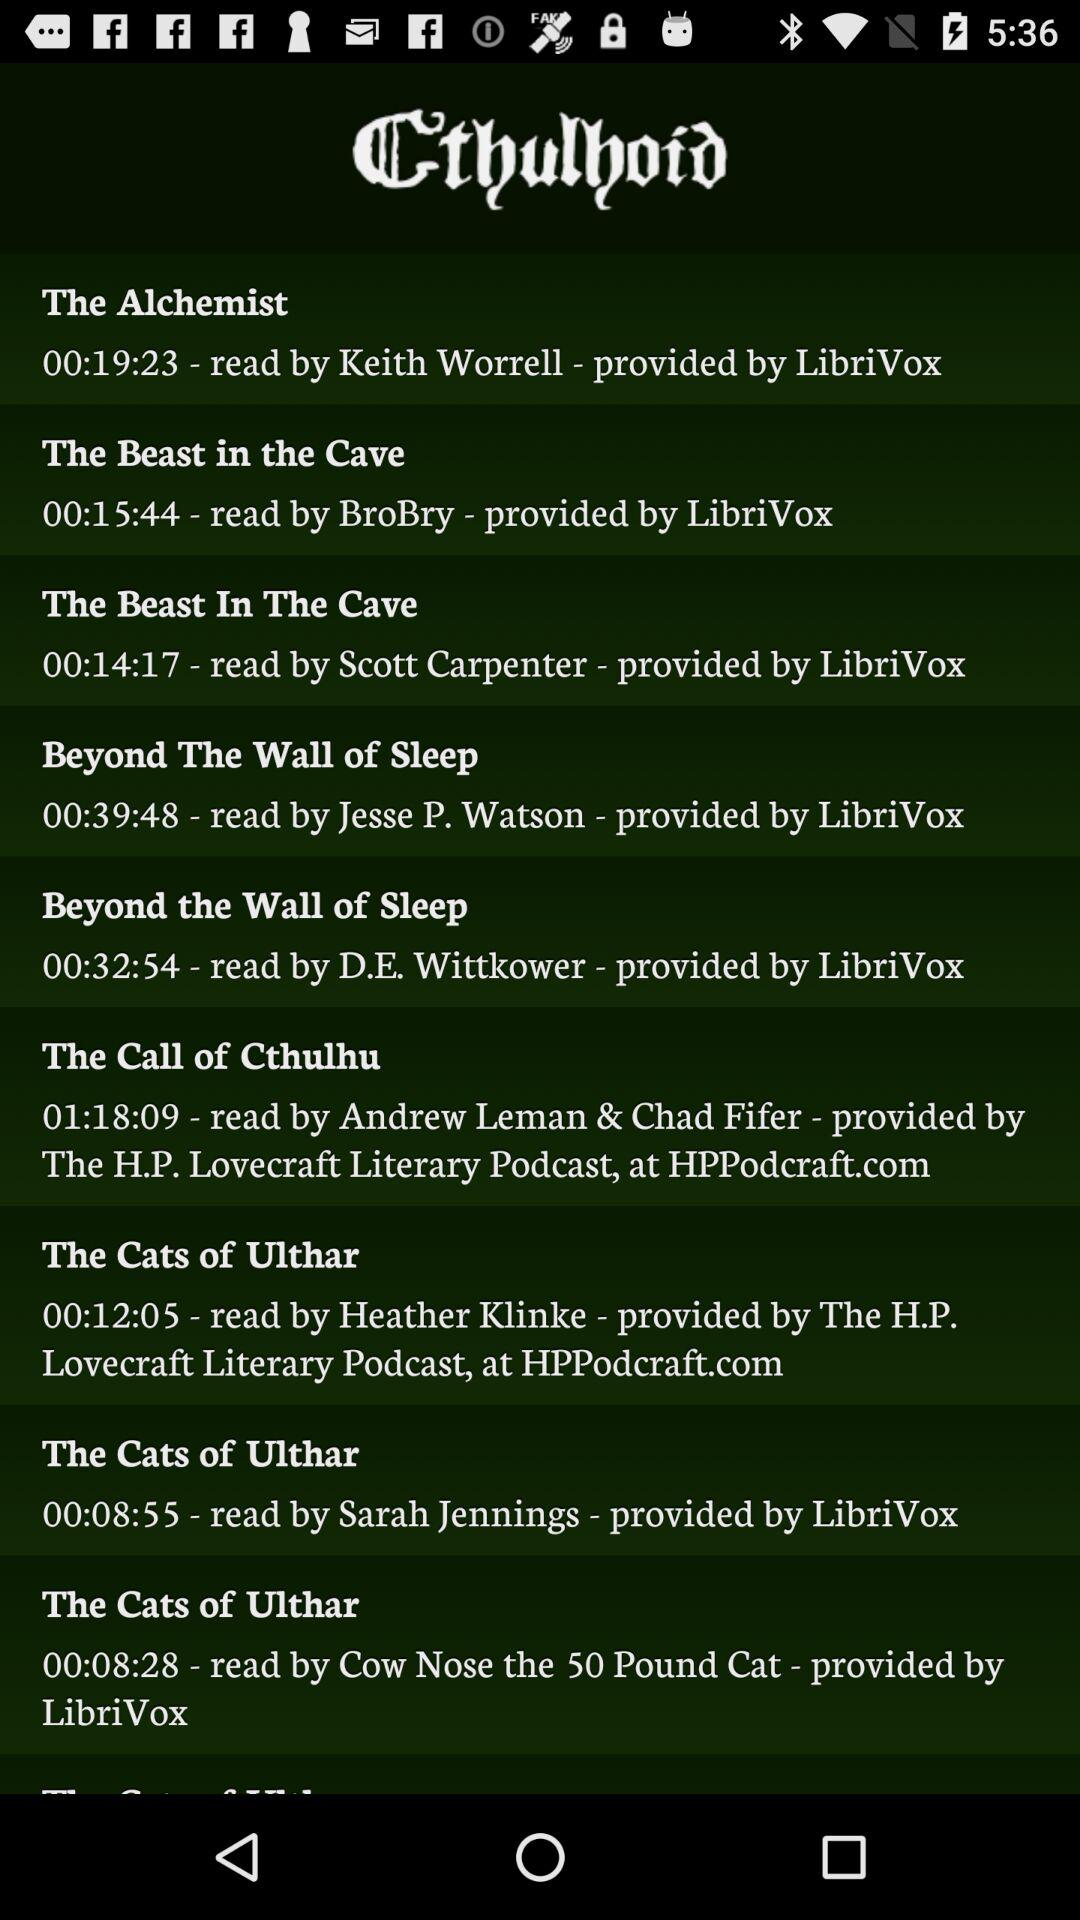What is the name of the reader of "The Alchemist"? The name of the reader of "The Alchemist" is Keith Worrell. 